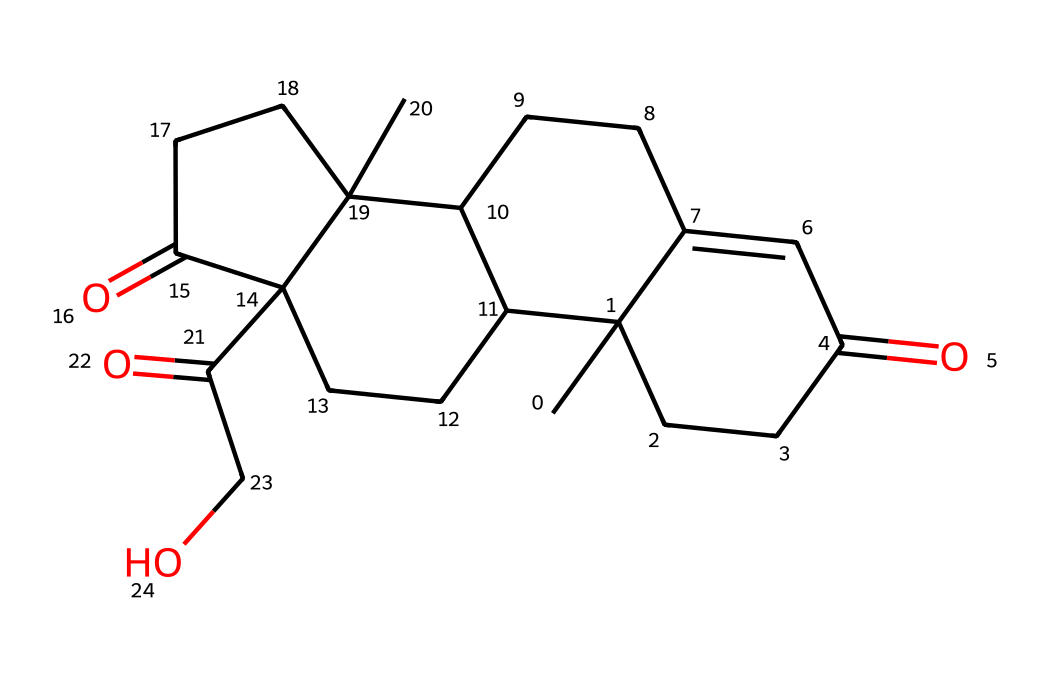how many carbon atoms are in cortisol? The molecular structure represented by the SMILES shows a total of 21 carbon atoms. Counting each "C" in the SMILES string gives a sum of 21.
Answer: 21 how many oxygen atoms are present in cortisol? The SMILES representation includes "O" four times, indicating that there are four oxygen atoms in the structure of cortisol.
Answer: 4 what is the molecular formula of cortisol? By analyzing the composition from the SMILES, we find that cortisol has a molecular formula of C21H30O5 based on the counts of carbon, hydrogen, and oxygen.
Answer: C21H30O5 does cortisol contain any double bonds? Yes, cortisol contains at least two double bonds, which can be identified by the "=" symbol in the SMILES representation.
Answer: yes what type of hormone is cortisol classified as? Cortisol is classified as a glucocorticoid, a type of steroid hormone that plays a significant role in glucose metabolism and stress response.
Answer: glucocorticoid how does the structure of cortisol relate to its function? The structure of cortisol, featuring multiple functional groups and rings, allows it to interact with glucocorticoid receptors, thus influencing stress responses and metabolic processes.
Answer: receptor interaction what characteristic feature of cortisol contributes to its solubility in lipids? The presence of steroid rings and hydrocarbon chains in cortisol's structure gives it lipophilic properties, making it soluble in lipids.
Answer: lipophilic properties 